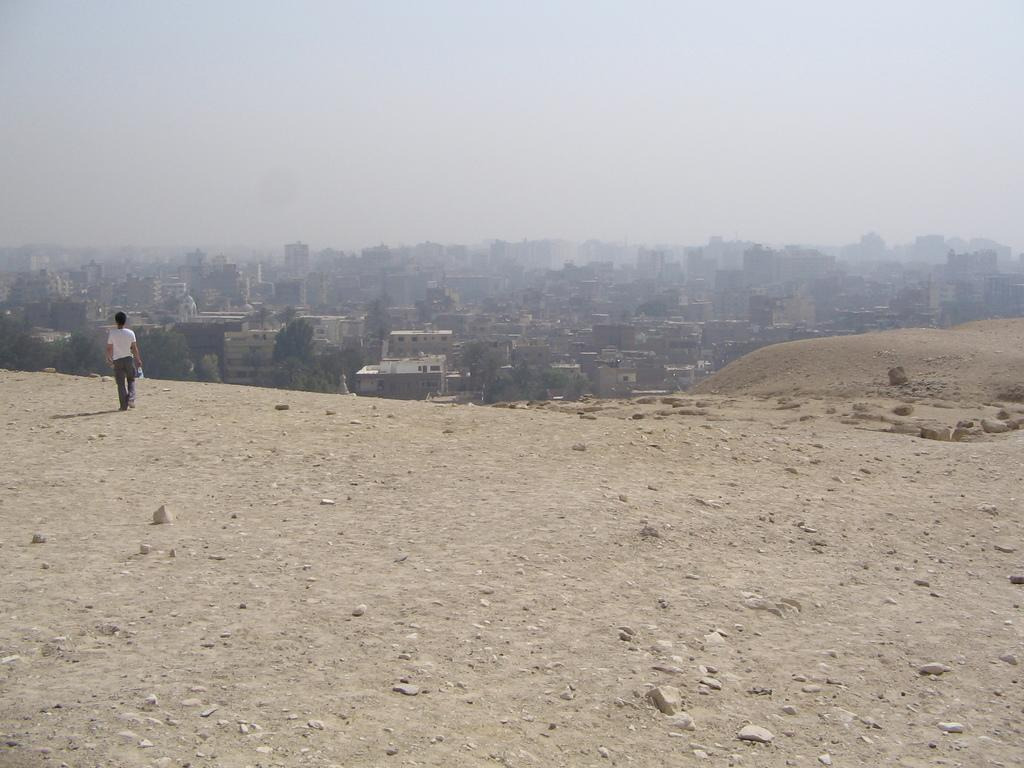What type of structures can be seen in the background of the image? There are buildings in the background of the image. What part of the natural environment is visible in the image? The sky is visible in the background of the image. What is at the bottom of the image? There is ground at the bottom of the image. What is the person in the image doing? There is a person walking in the image. Where is the hose located in the image? There is no hose present in the image. What type of nest can be seen in the image? There is no nest present in the image. 